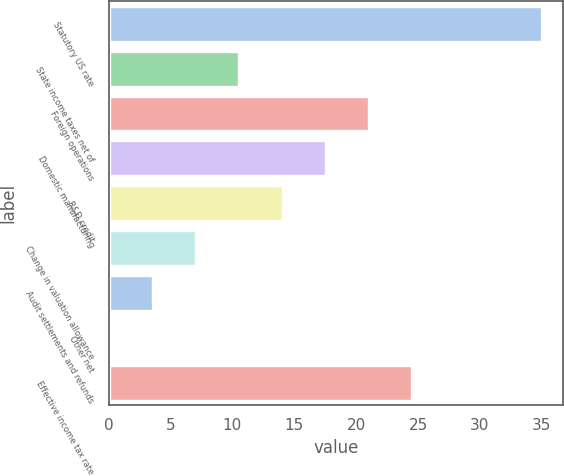Convert chart to OTSL. <chart><loc_0><loc_0><loc_500><loc_500><bar_chart><fcel>Statutory US rate<fcel>State income taxes net of<fcel>Foreign operations<fcel>Domestic manufacturing<fcel>R&D credit<fcel>Change in valuation allowance<fcel>Audit settlements and refunds<fcel>Other net<fcel>Effective income tax rate<nl><fcel>35<fcel>10.57<fcel>21.04<fcel>17.55<fcel>14.06<fcel>7.08<fcel>3.59<fcel>0.1<fcel>24.53<nl></chart> 